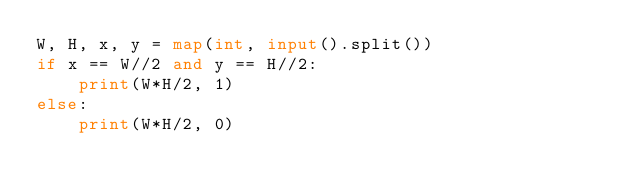Convert code to text. <code><loc_0><loc_0><loc_500><loc_500><_Python_>W, H, x, y = map(int, input().split())
if x == W//2 and y == H//2:
    print(W*H/2, 1)
else:
    print(W*H/2, 0)</code> 